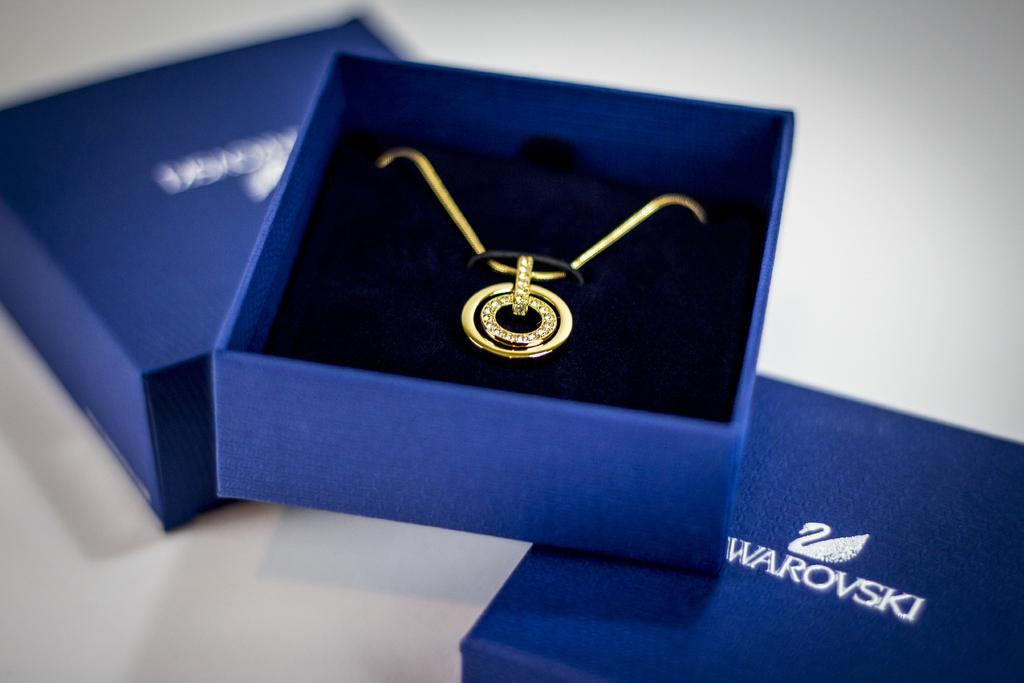<image>
Summarize the visual content of the image. the name warovski that is on a blue box 